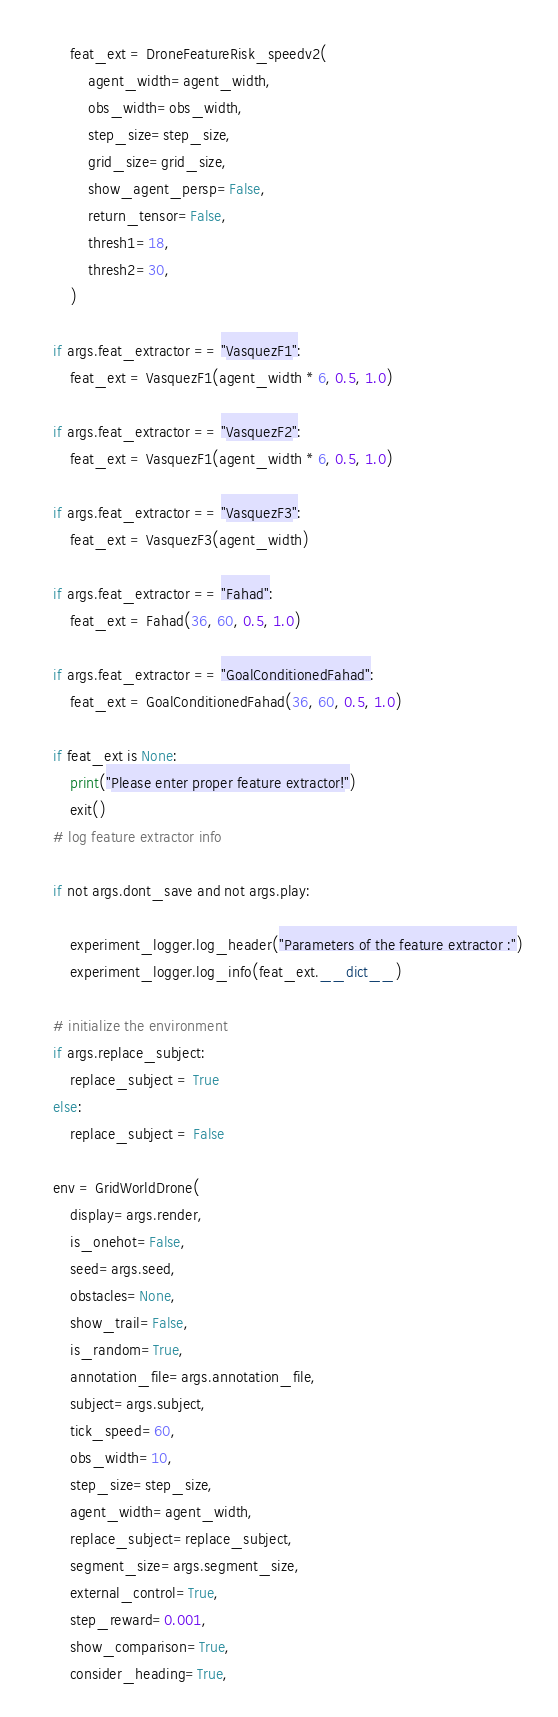<code> <loc_0><loc_0><loc_500><loc_500><_Python_>
        feat_ext = DroneFeatureRisk_speedv2(
            agent_width=agent_width,
            obs_width=obs_width,
            step_size=step_size,
            grid_size=grid_size,
            show_agent_persp=False,
            return_tensor=False,
            thresh1=18,
            thresh2=30,
        )

    if args.feat_extractor == "VasquezF1":
        feat_ext = VasquezF1(agent_width * 6, 0.5, 1.0)

    if args.feat_extractor == "VasquezF2":
        feat_ext = VasquezF1(agent_width * 6, 0.5, 1.0)

    if args.feat_extractor == "VasquezF3":
        feat_ext = VasquezF3(agent_width)

    if args.feat_extractor == "Fahad":
        feat_ext = Fahad(36, 60, 0.5, 1.0)

    if args.feat_extractor == "GoalConditionedFahad":
        feat_ext = GoalConditionedFahad(36, 60, 0.5, 1.0)

    if feat_ext is None:
        print("Please enter proper feature extractor!")
        exit()
    # log feature extractor info

    if not args.dont_save and not args.play:

        experiment_logger.log_header("Parameters of the feature extractor :")
        experiment_logger.log_info(feat_ext.__dict__)

    # initialize the environment
    if args.replace_subject:
        replace_subject = True
    else:
        replace_subject = False

    env = GridWorldDrone(
        display=args.render,
        is_onehot=False,
        seed=args.seed,
        obstacles=None,
        show_trail=False,
        is_random=True,
        annotation_file=args.annotation_file,
        subject=args.subject,
        tick_speed=60,
        obs_width=10,
        step_size=step_size,
        agent_width=agent_width,
        replace_subject=replace_subject,
        segment_size=args.segment_size,
        external_control=True,
        step_reward=0.001,
        show_comparison=True,
        consider_heading=True,</code> 